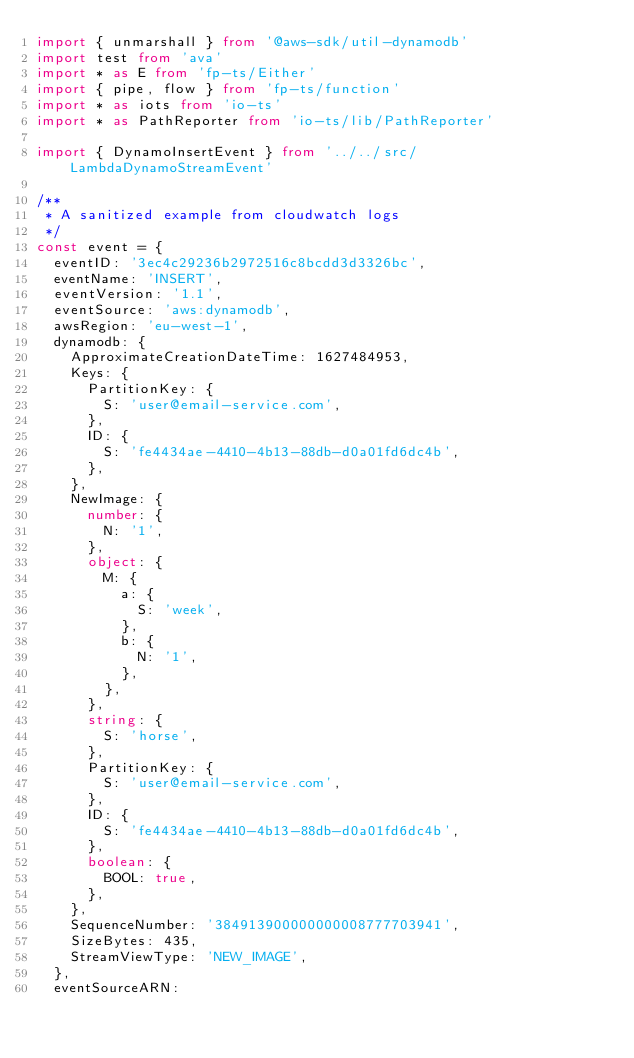<code> <loc_0><loc_0><loc_500><loc_500><_TypeScript_>import { unmarshall } from '@aws-sdk/util-dynamodb'
import test from 'ava'
import * as E from 'fp-ts/Either'
import { pipe, flow } from 'fp-ts/function'
import * as iots from 'io-ts'
import * as PathReporter from 'io-ts/lib/PathReporter'

import { DynamoInsertEvent } from '../../src/LambdaDynamoStreamEvent'

/**
 * A sanitized example from cloudwatch logs
 */
const event = {
  eventID: '3ec4c29236b2972516c8bcdd3d3326bc',
  eventName: 'INSERT',
  eventVersion: '1.1',
  eventSource: 'aws:dynamodb',
  awsRegion: 'eu-west-1',
  dynamodb: {
    ApproximateCreationDateTime: 1627484953,
    Keys: {
      PartitionKey: {
        S: 'user@email-service.com',
      },
      ID: {
        S: 'fe4434ae-4410-4b13-88db-d0a01fd6dc4b',
      },
    },
    NewImage: {
      number: {
        N: '1',
      },
      object: {
        M: {
          a: {
            S: 'week',
          },
          b: {
            N: '1',
          },
        },
      },
      string: {
        S: 'horse',
      },
      PartitionKey: {
        S: 'user@email-service.com',
      },
      ID: {
        S: 'fe4434ae-4410-4b13-88db-d0a01fd6dc4b',
      },
      boolean: {
        BOOL: true,
      },
    },
    SequenceNumber: '384913900000000008777703941',
    SizeBytes: 435,
    StreamViewType: 'NEW_IMAGE',
  },
  eventSourceARN:</code> 